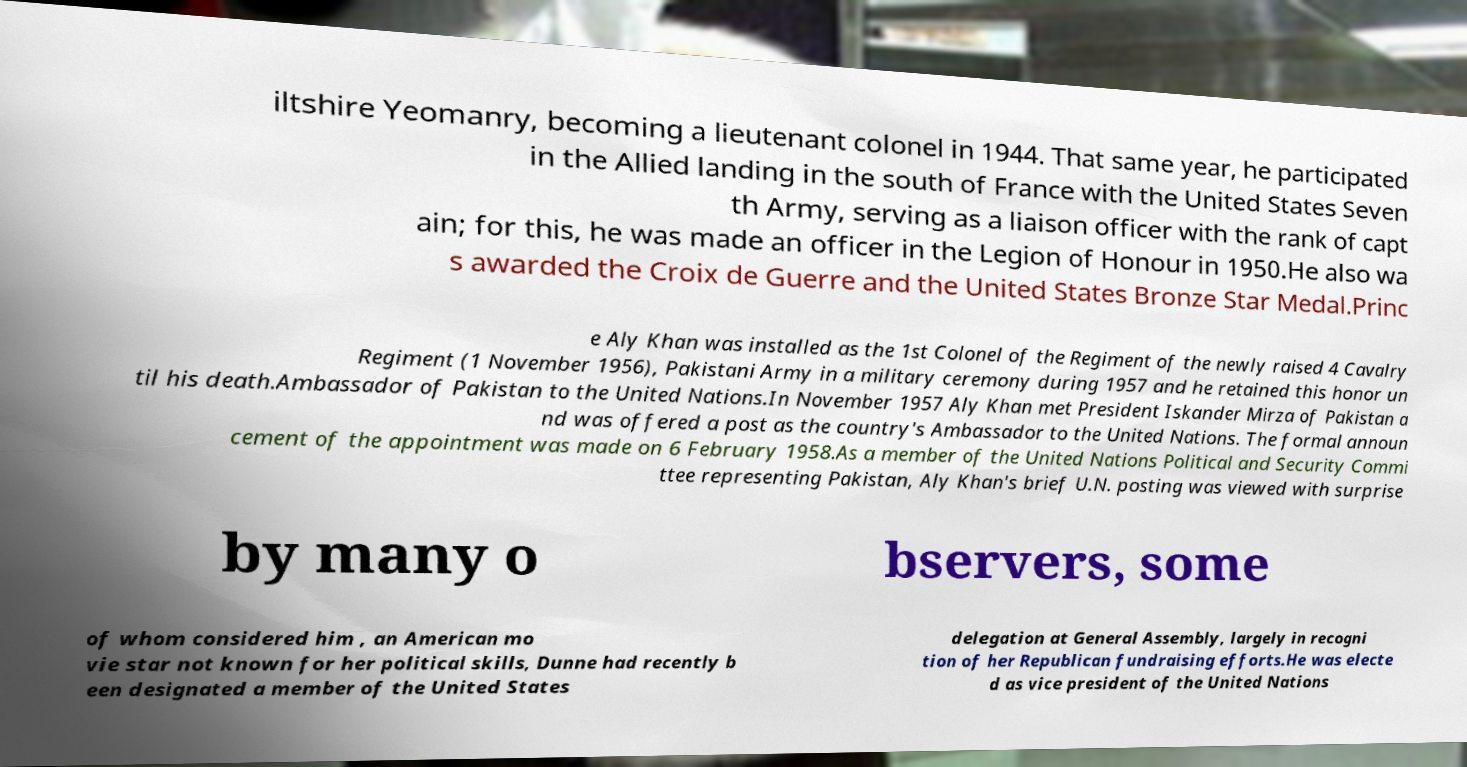Could you assist in decoding the text presented in this image and type it out clearly? iltshire Yeomanry, becoming a lieutenant colonel in 1944. That same year, he participated in the Allied landing in the south of France with the United States Seven th Army, serving as a liaison officer with the rank of capt ain; for this, he was made an officer in the Legion of Honour in 1950.He also wa s awarded the Croix de Guerre and the United States Bronze Star Medal.Princ e Aly Khan was installed as the 1st Colonel of the Regiment of the newly raised 4 Cavalry Regiment (1 November 1956), Pakistani Army in a military ceremony during 1957 and he retained this honor un til his death.Ambassador of Pakistan to the United Nations.In November 1957 Aly Khan met President Iskander Mirza of Pakistan a nd was offered a post as the country's Ambassador to the United Nations. The formal announ cement of the appointment was made on 6 February 1958.As a member of the United Nations Political and Security Commi ttee representing Pakistan, Aly Khan's brief U.N. posting was viewed with surprise by many o bservers, some of whom considered him , an American mo vie star not known for her political skills, Dunne had recently b een designated a member of the United States delegation at General Assembly, largely in recogni tion of her Republican fundraising efforts.He was electe d as vice president of the United Nations 